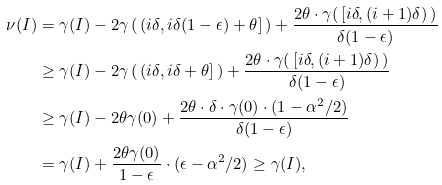Convert formula to latex. <formula><loc_0><loc_0><loc_500><loc_500>\nu ( I ) & = \gamma ( I ) - 2 \gamma \left ( \, ( i \delta , i \delta ( 1 - \epsilon ) + \theta ] \, \right ) + \frac { 2 \theta \cdot \gamma ( \, [ i \delta , ( i + 1 ) \delta ) \, ) } { \delta ( 1 - \epsilon ) } \\ & \geq \gamma ( I ) - 2 \gamma \left ( \, ( i \delta , i \delta + \theta ] \, \right ) + \frac { 2 \theta \cdot \gamma ( \, [ i \delta , ( i + 1 ) \delta ) \, ) } { \delta ( 1 - \epsilon ) } \\ & \geq \gamma ( I ) - 2 \theta \gamma ( 0 ) + \frac { 2 \theta \cdot \delta \cdot \gamma ( 0 ) \cdot ( 1 - \alpha ^ { 2 } / 2 ) } { \delta ( 1 - \epsilon ) } \\ & = \gamma ( I ) + \frac { 2 \theta \gamma ( 0 ) } { 1 - \epsilon } \cdot ( \epsilon - \alpha ^ { 2 } / 2 ) \geq \gamma ( I ) ,</formula> 